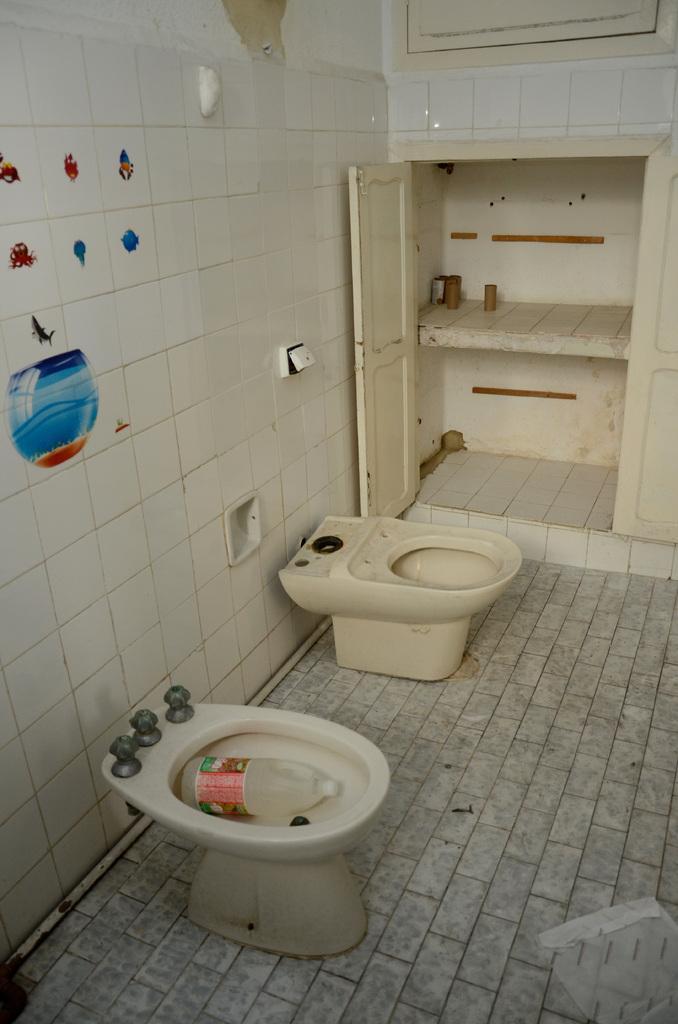Can you describe this image briefly? This picture is taken inside the room. In this image, on the left side, we can see two toilets. In the background, there is a shelf and doors. On the left side, we can also see some tiles, paintings. 